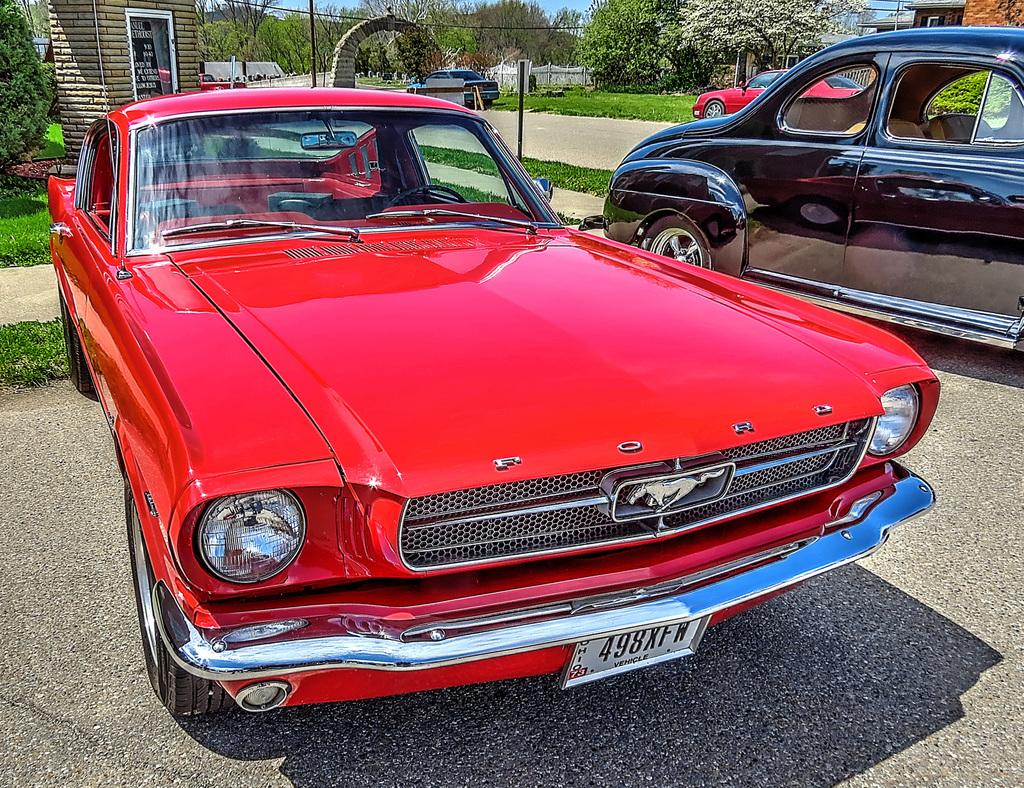What type of vehicles can be seen on the ground in the image? There are cars on the ground in the image. What type of vegetation is visible in the image? Grass and trees are present in the image. What type of structure can be seen in the image? There is an arch in the image. What type of man-made structures are visible in the image? Buildings are visible in the image. What else can be seen in the image besides the mentioned objects? There are some unspecified objects in the image. What can be seen in the background of the image? The sky is visible in the background of the image. Can you describe the laborer working on the suit in the image? There is no laborer or suit present in the image. What is the afterthought of the person who designed the image? We cannot determine the afterthought of the person who designed the image from the information provided. 